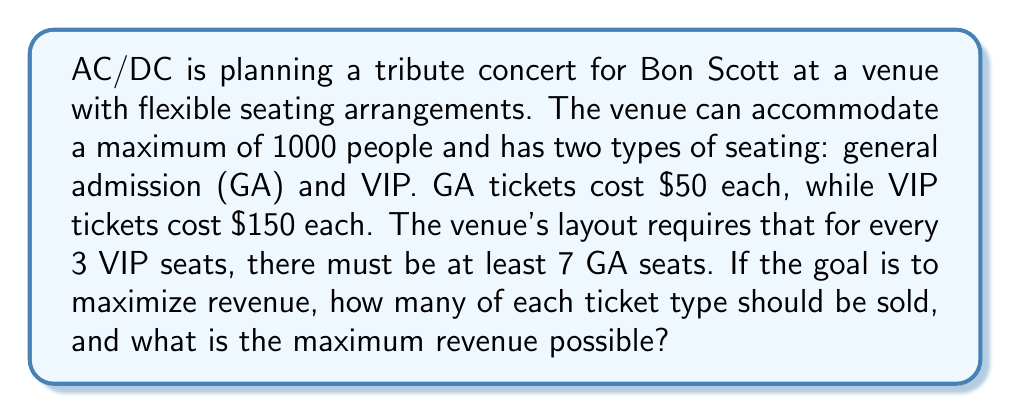Provide a solution to this math problem. Let's approach this step-by-step using linear programming:

1) Define variables:
   Let $x$ = number of GA tickets
   Let $y$ = number of VIP tickets

2) Objective function (revenue):
   $R = 50x + 150y$ (maximize this)

3) Constraints:
   a) Total capacity: $x + y \leq 1000$
   b) Seating ratio: $7y \leq 3x$ or $7y - 3x \leq 0$
   c) Non-negativity: $x \geq 0, y \geq 0$

4) Set up the linear programming problem:
   Maximize $R = 50x + 150y$
   Subject to:
   $x + y \leq 1000$
   $7y - 3x \leq 0$
   $x \geq 0, y \geq 0$

5) Solve graphically or using the simplex method. The optimal solution will be at one of the corner points of the feasible region.

6) The corner points are:
   (0, 0), (1000, 0), (700, 300)

7) Evaluate the objective function at these points:
   R(0, 0) = 0
   R(1000, 0) = 50,000
   R(700, 300) = 35,000 + 45,000 = 80,000

8) The maximum revenue occurs at (700, 300), meaning 700 GA tickets and 300 VIP tickets should be sold.
Answer: The optimal solution is to sell 700 GA tickets and 300 VIP tickets, resulting in a maximum revenue of $80,000. 